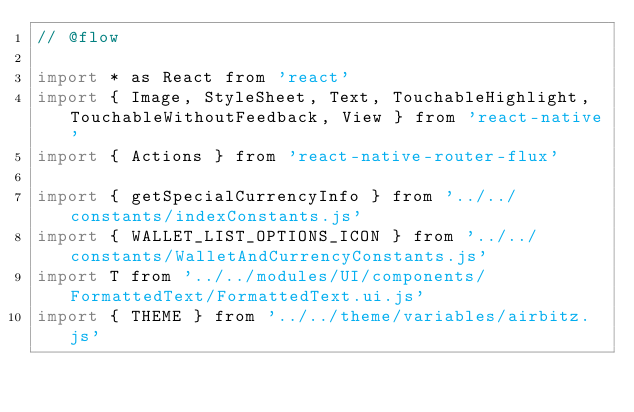Convert code to text. <code><loc_0><loc_0><loc_500><loc_500><_JavaScript_>// @flow

import * as React from 'react'
import { Image, StyleSheet, Text, TouchableHighlight, TouchableWithoutFeedback, View } from 'react-native'
import { Actions } from 'react-native-router-flux'

import { getSpecialCurrencyInfo } from '../../constants/indexConstants.js'
import { WALLET_LIST_OPTIONS_ICON } from '../../constants/WalletAndCurrencyConstants.js'
import T from '../../modules/UI/components/FormattedText/FormattedText.ui.js'
import { THEME } from '../../theme/variables/airbitz.js'</code> 